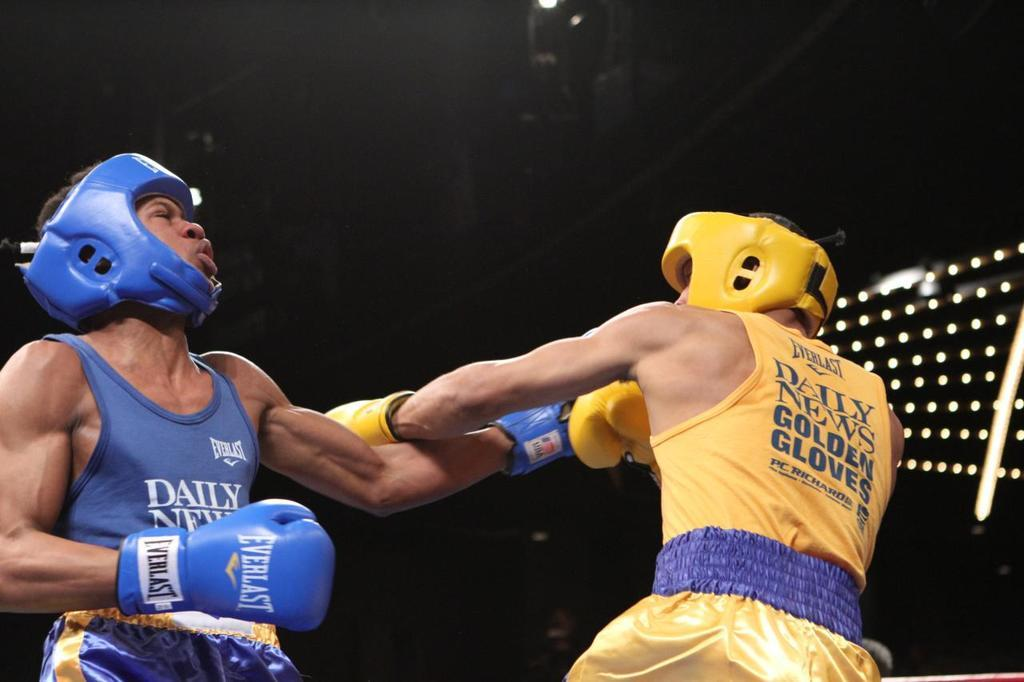Provide a one-sentence caption for the provided image. the word daily is on the shirt of a boxer. 